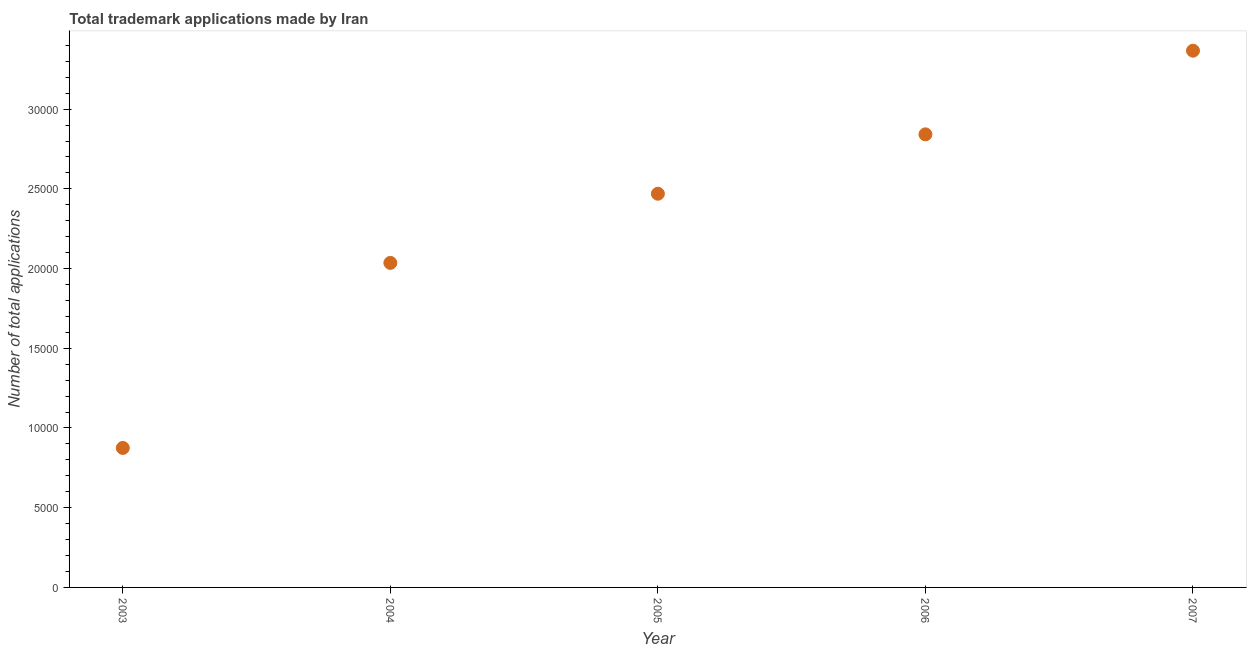What is the number of trademark applications in 2006?
Keep it short and to the point. 2.84e+04. Across all years, what is the maximum number of trademark applications?
Offer a terse response. 3.37e+04. Across all years, what is the minimum number of trademark applications?
Offer a very short reply. 8748. What is the sum of the number of trademark applications?
Ensure brevity in your answer.  1.16e+05. What is the difference between the number of trademark applications in 2003 and 2006?
Provide a succinct answer. -1.97e+04. What is the average number of trademark applications per year?
Offer a very short reply. 2.32e+04. What is the median number of trademark applications?
Your answer should be very brief. 2.47e+04. What is the ratio of the number of trademark applications in 2005 to that in 2006?
Provide a succinct answer. 0.87. Is the difference between the number of trademark applications in 2004 and 2007 greater than the difference between any two years?
Make the answer very short. No. What is the difference between the highest and the second highest number of trademark applications?
Give a very brief answer. 5247. Is the sum of the number of trademark applications in 2004 and 2005 greater than the maximum number of trademark applications across all years?
Provide a short and direct response. Yes. What is the difference between the highest and the lowest number of trademark applications?
Give a very brief answer. 2.49e+04. In how many years, is the number of trademark applications greater than the average number of trademark applications taken over all years?
Ensure brevity in your answer.  3. How many years are there in the graph?
Ensure brevity in your answer.  5. Does the graph contain grids?
Give a very brief answer. No. What is the title of the graph?
Provide a short and direct response. Total trademark applications made by Iran. What is the label or title of the Y-axis?
Your response must be concise. Number of total applications. What is the Number of total applications in 2003?
Your response must be concise. 8748. What is the Number of total applications in 2004?
Provide a short and direct response. 2.04e+04. What is the Number of total applications in 2005?
Provide a short and direct response. 2.47e+04. What is the Number of total applications in 2006?
Offer a very short reply. 2.84e+04. What is the Number of total applications in 2007?
Keep it short and to the point. 3.37e+04. What is the difference between the Number of total applications in 2003 and 2004?
Your response must be concise. -1.16e+04. What is the difference between the Number of total applications in 2003 and 2005?
Your answer should be very brief. -1.59e+04. What is the difference between the Number of total applications in 2003 and 2006?
Give a very brief answer. -1.97e+04. What is the difference between the Number of total applications in 2003 and 2007?
Your response must be concise. -2.49e+04. What is the difference between the Number of total applications in 2004 and 2005?
Your answer should be very brief. -4339. What is the difference between the Number of total applications in 2004 and 2006?
Your answer should be very brief. -8063. What is the difference between the Number of total applications in 2004 and 2007?
Your response must be concise. -1.33e+04. What is the difference between the Number of total applications in 2005 and 2006?
Give a very brief answer. -3724. What is the difference between the Number of total applications in 2005 and 2007?
Your answer should be very brief. -8971. What is the difference between the Number of total applications in 2006 and 2007?
Provide a succinct answer. -5247. What is the ratio of the Number of total applications in 2003 to that in 2004?
Offer a very short reply. 0.43. What is the ratio of the Number of total applications in 2003 to that in 2005?
Offer a very short reply. 0.35. What is the ratio of the Number of total applications in 2003 to that in 2006?
Your response must be concise. 0.31. What is the ratio of the Number of total applications in 2003 to that in 2007?
Your answer should be very brief. 0.26. What is the ratio of the Number of total applications in 2004 to that in 2005?
Make the answer very short. 0.82. What is the ratio of the Number of total applications in 2004 to that in 2006?
Offer a very short reply. 0.72. What is the ratio of the Number of total applications in 2004 to that in 2007?
Provide a short and direct response. 0.6. What is the ratio of the Number of total applications in 2005 to that in 2006?
Your answer should be very brief. 0.87. What is the ratio of the Number of total applications in 2005 to that in 2007?
Offer a terse response. 0.73. What is the ratio of the Number of total applications in 2006 to that in 2007?
Your answer should be very brief. 0.84. 